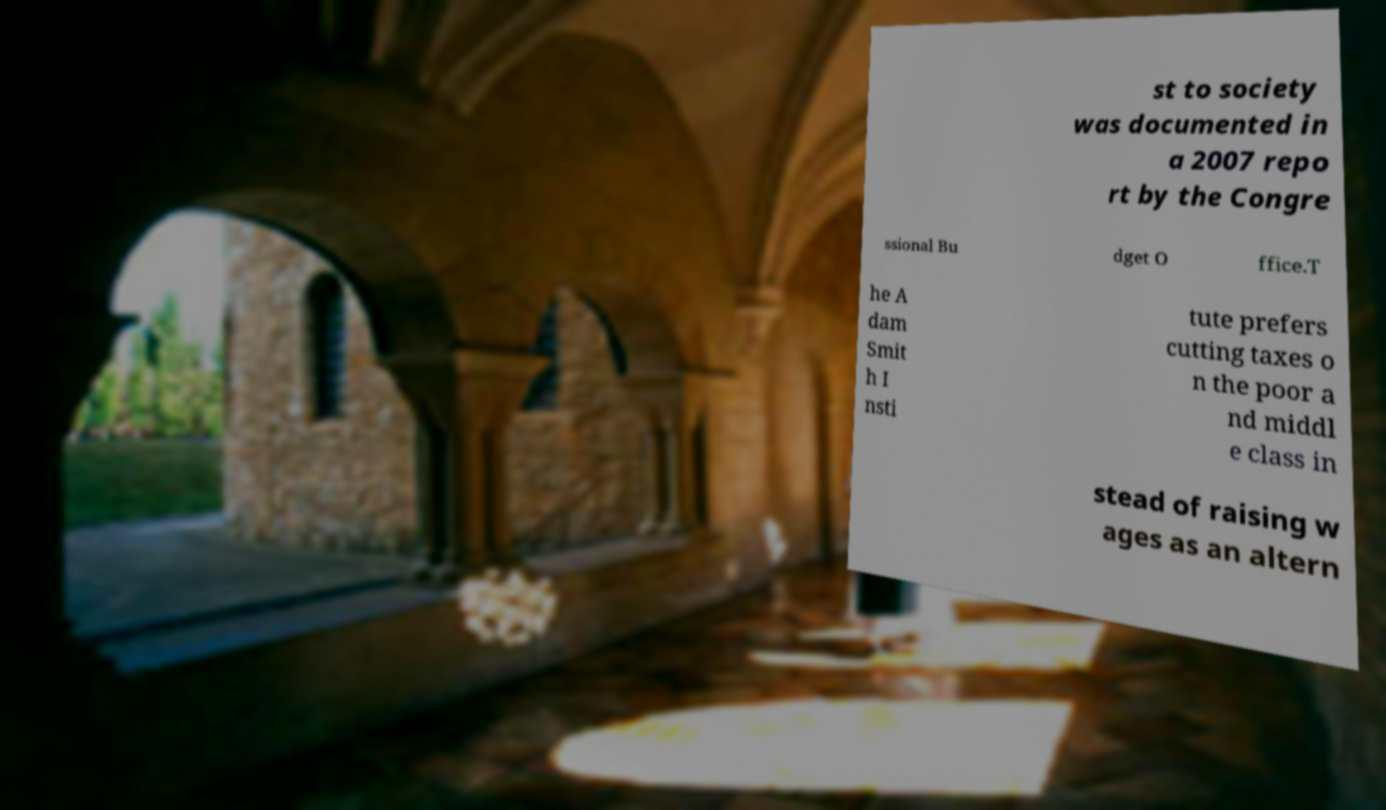For documentation purposes, I need the text within this image transcribed. Could you provide that? st to society was documented in a 2007 repo rt by the Congre ssional Bu dget O ffice.T he A dam Smit h I nsti tute prefers cutting taxes o n the poor a nd middl e class in stead of raising w ages as an altern 